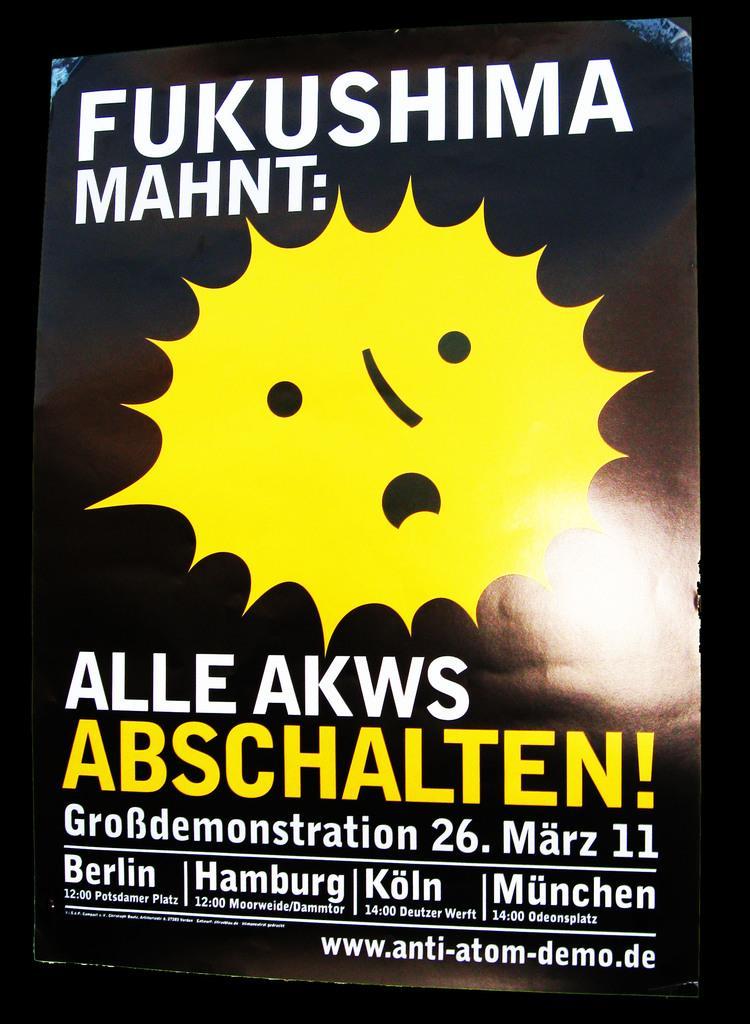Could you give a brief overview of what you see in this image? This is a poster and in this poster we can see some text and in the background it is dark. 